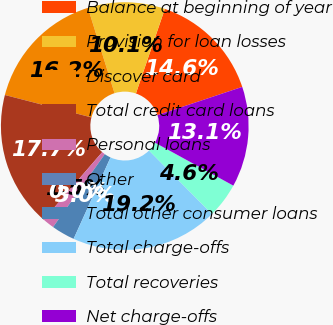<chart> <loc_0><loc_0><loc_500><loc_500><pie_chart><fcel>Balance at beginning of year<fcel>Provision for loan losses<fcel>Discover card<fcel>Total credit card loans<fcel>Personal loans<fcel>Other<fcel>Total other consumer loans<fcel>Total charge-offs<fcel>Total recoveries<fcel>Net charge-offs<nl><fcel>14.63%<fcel>10.05%<fcel>16.16%<fcel>17.68%<fcel>1.53%<fcel>0.0%<fcel>3.05%<fcel>19.21%<fcel>4.58%<fcel>13.11%<nl></chart> 